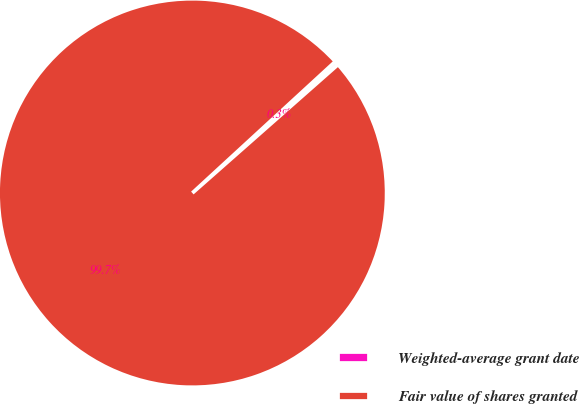<chart> <loc_0><loc_0><loc_500><loc_500><pie_chart><fcel>Weighted-average grant date<fcel>Fair value of shares granted<nl><fcel>0.33%<fcel>99.67%<nl></chart> 